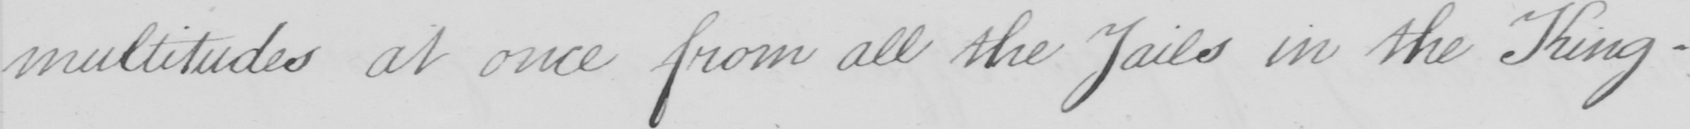What is written in this line of handwriting? multitudes at once from all the Jails in the King- 